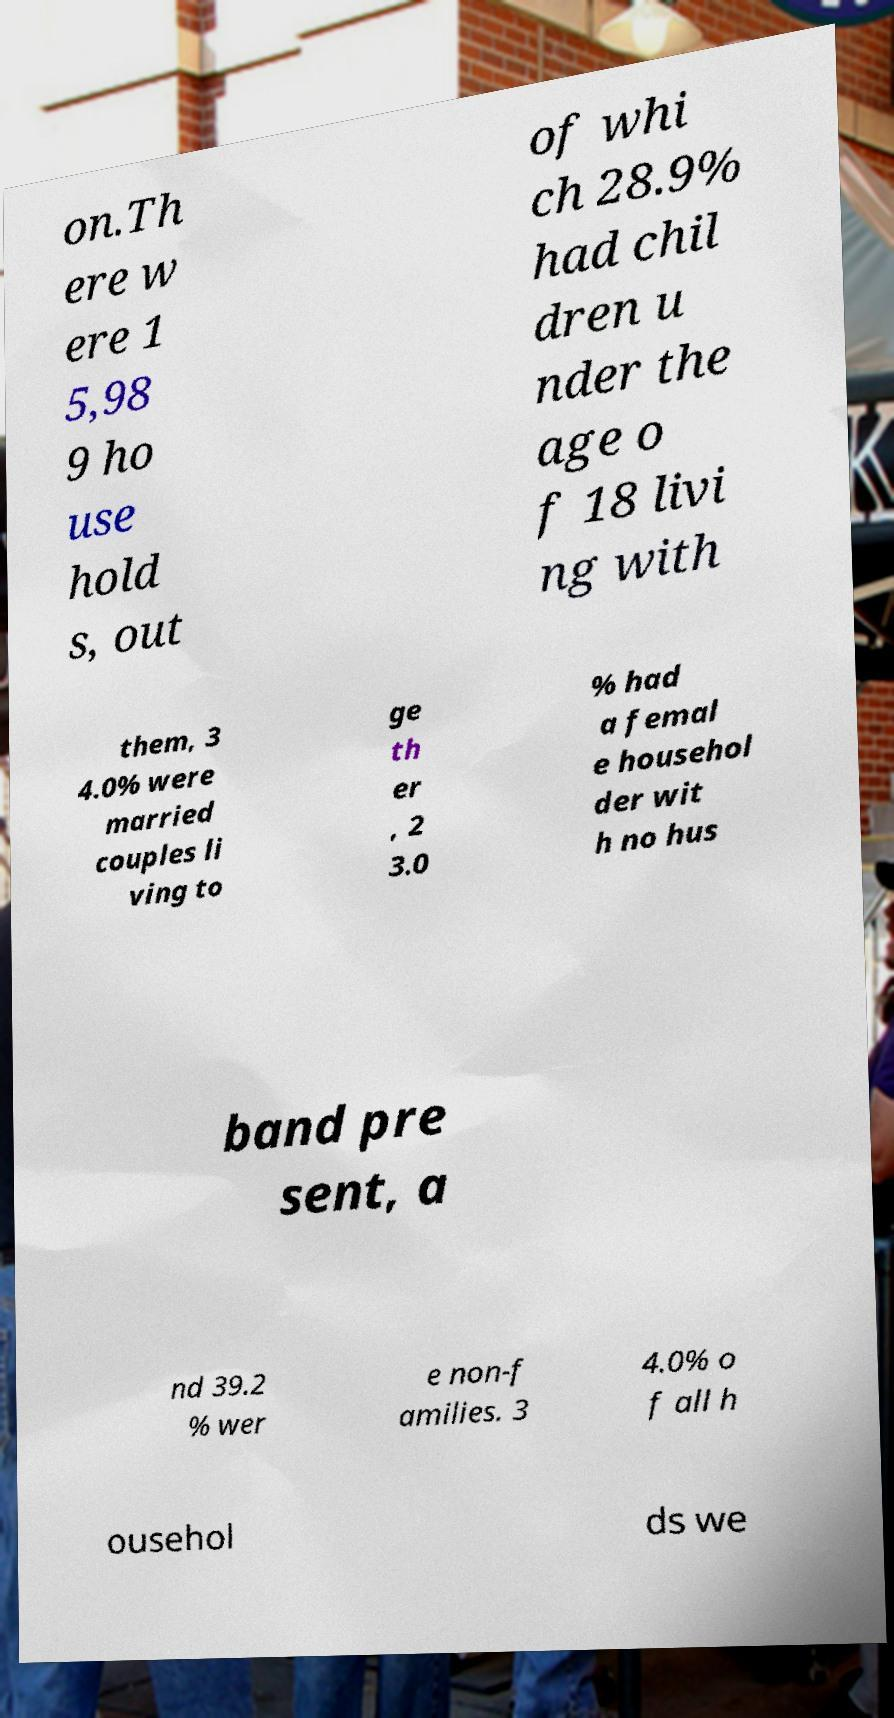What messages or text are displayed in this image? I need them in a readable, typed format. on.Th ere w ere 1 5,98 9 ho use hold s, out of whi ch 28.9% had chil dren u nder the age o f 18 livi ng with them, 3 4.0% were married couples li ving to ge th er , 2 3.0 % had a femal e househol der wit h no hus band pre sent, a nd 39.2 % wer e non-f amilies. 3 4.0% o f all h ousehol ds we 